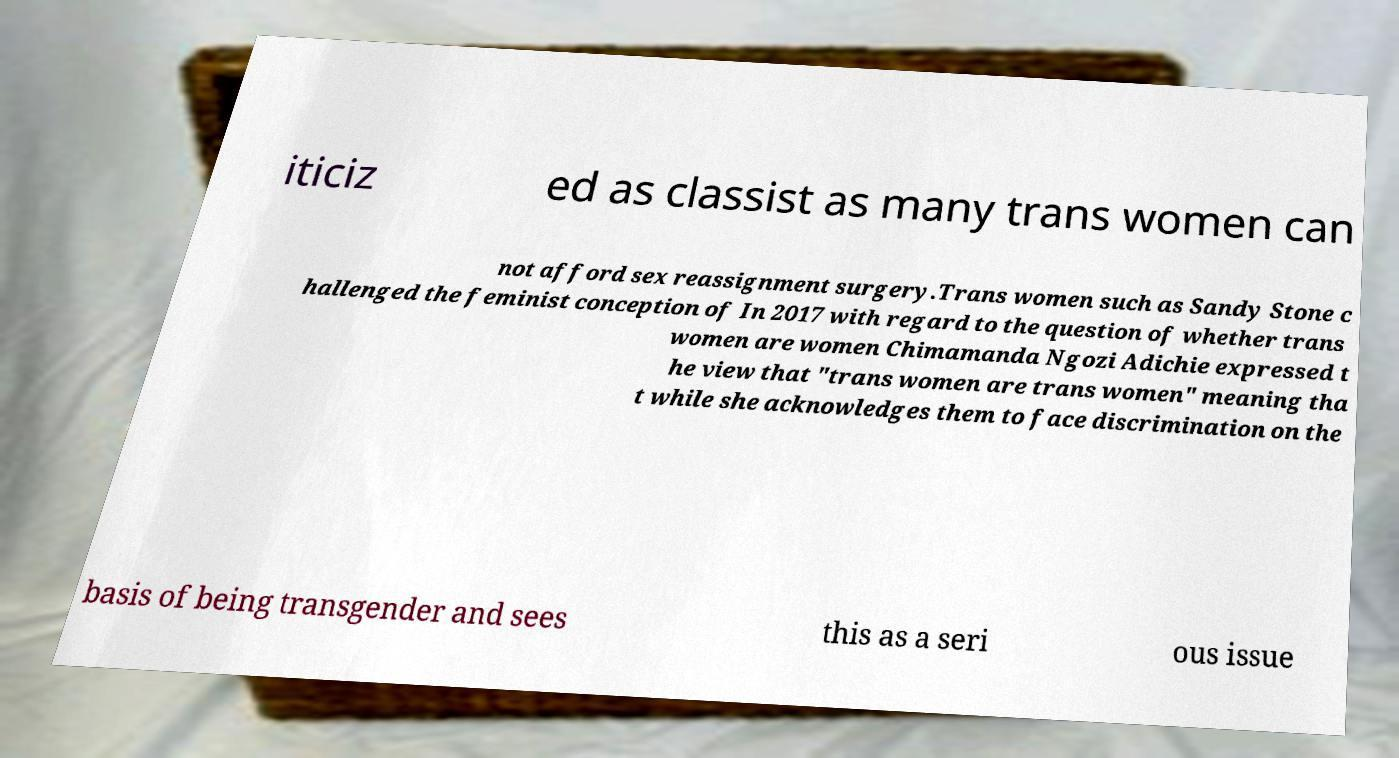There's text embedded in this image that I need extracted. Can you transcribe it verbatim? iticiz ed as classist as many trans women can not afford sex reassignment surgery.Trans women such as Sandy Stone c hallenged the feminist conception of In 2017 with regard to the question of whether trans women are women Chimamanda Ngozi Adichie expressed t he view that "trans women are trans women" meaning tha t while she acknowledges them to face discrimination on the basis of being transgender and sees this as a seri ous issue 